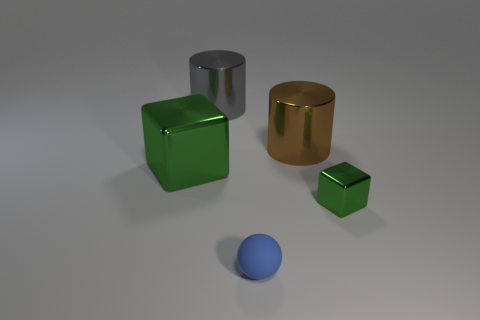The metallic block that is to the right of the green metal object that is behind the thing on the right side of the brown metal object is what color?
Ensure brevity in your answer.  Green. Do the big gray object and the brown thing have the same material?
Make the answer very short. Yes. There is a cube behind the block to the right of the large cube; is there a large cylinder on the left side of it?
Make the answer very short. No. Does the small shiny thing have the same color as the small matte object?
Make the answer very short. No. Are there fewer brown objects than big red rubber cubes?
Offer a very short reply. No. Is the green block that is in front of the large green shiny thing made of the same material as the big brown cylinder that is behind the small green thing?
Your answer should be very brief. Yes. Are there fewer metallic objects behind the blue rubber sphere than big green objects?
Keep it short and to the point. No. There is a metal block left of the small matte sphere; what number of metallic objects are right of it?
Provide a succinct answer. 3. There is a object that is both in front of the big green shiny block and behind the small blue thing; what size is it?
Offer a very short reply. Small. Is there anything else that is made of the same material as the brown thing?
Ensure brevity in your answer.  Yes. 